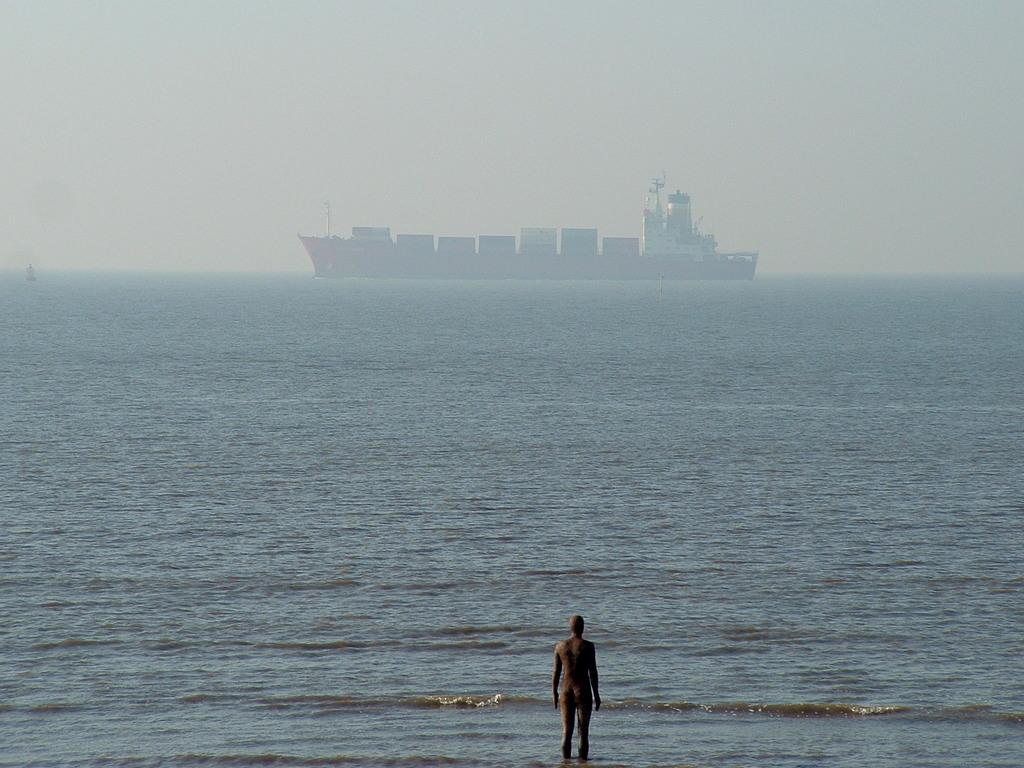What is the main feature in the center of the image? There is water in the center of the image. Can you describe the person in the image? There is a person standing in the front of the image. What else can be seen on the water? There is a ship visible on the water. What type of porter is carrying the receipt in the shade in the image? There is no porter, receipt, or shade present in the image. 